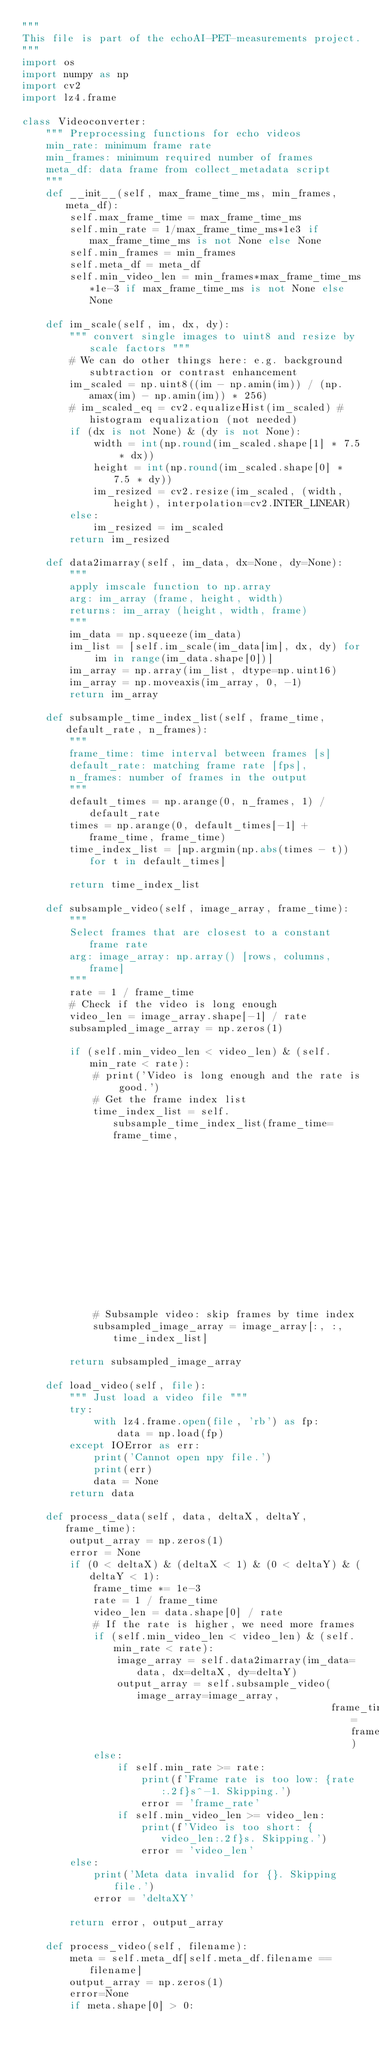<code> <loc_0><loc_0><loc_500><loc_500><_Python_>"""
This file is part of the echoAI-PET-measurements project.
"""
import os
import numpy as np
import cv2
import lz4.frame

class Videoconverter:
    """ Preprocessing functions for echo videos
    min_rate: minimum frame rate
    min_frames: minimum required number of frames
    meta_df: data frame from collect_metadata script
    """
    def __init__(self, max_frame_time_ms, min_frames, meta_df):
        self.max_frame_time = max_frame_time_ms
        self.min_rate = 1/max_frame_time_ms*1e3 if max_frame_time_ms is not None else None
        self.min_frames = min_frames
        self.meta_df = meta_df
        self.min_video_len = min_frames*max_frame_time_ms*1e-3 if max_frame_time_ms is not None else None

    def im_scale(self, im, dx, dy):
        """ convert single images to uint8 and resize by scale factors """
        # We can do other things here: e.g. background subtraction or contrast enhancement
        im_scaled = np.uint8((im - np.amin(im)) / (np.amax(im) - np.amin(im)) * 256)
        # im_scaled_eq = cv2.equalizeHist(im_scaled) # histogram equalization (not needed)
        if (dx is not None) & (dy is not None):
            width = int(np.round(im_scaled.shape[1] * 7.5 * dx))
            height = int(np.round(im_scaled.shape[0] * 7.5 * dy))
            im_resized = cv2.resize(im_scaled, (width, height), interpolation=cv2.INTER_LINEAR)
        else:
            im_resized = im_scaled
        return im_resized

    def data2imarray(self, im_data, dx=None, dy=None):
        """
        apply imscale function to np.array
        arg: im_array (frame, height, width)
        returns: im_array (height, width, frame)
        """
        im_data = np.squeeze(im_data)
        im_list = [self.im_scale(im_data[im], dx, dy) for im in range(im_data.shape[0])]
        im_array = np.array(im_list, dtype=np.uint16)
        im_array = np.moveaxis(im_array, 0, -1)
        return im_array

    def subsample_time_index_list(self, frame_time, default_rate, n_frames):
        """
        frame_time: time interval between frames [s]
        default_rate: matching frame rate [fps],
        n_frames: number of frames in the output
        """
        default_times = np.arange(0, n_frames, 1) / default_rate
        times = np.arange(0, default_times[-1] + frame_time, frame_time)
        time_index_list = [np.argmin(np.abs(times - t)) for t in default_times]

        return time_index_list

    def subsample_video(self, image_array, frame_time):
        """
        Select frames that are closest to a constant frame rate
        arg: image_array: np.array() [rows, columns, frame]
        """
        rate = 1 / frame_time
        # Check if the video is long enough
        video_len = image_array.shape[-1] / rate
        subsampled_image_array = np.zeros(1)

        if (self.min_video_len < video_len) & (self.min_rate < rate):
            # print('Video is long enough and the rate is good.')
            # Get the frame index list
            time_index_list = self.subsample_time_index_list(frame_time=frame_time,
                                                             default_rate=self.min_rate,
                                                             n_frames=self.min_frames)
            # Subsample video: skip frames by time index
            subsampled_image_array = image_array[:, :, time_index_list]

        return subsampled_image_array

    def load_video(self, file):
        """ Just load a video file """
        try:
            with lz4.frame.open(file, 'rb') as fp:
                data = np.load(fp)
        except IOError as err:
            print('Cannot open npy file.')
            print(err)
            data = None
        return data

    def process_data(self, data, deltaX, deltaY, frame_time):
        output_array = np.zeros(1)
        error = None
        if (0 < deltaX) & (deltaX < 1) & (0 < deltaY) & (deltaY < 1):
            frame_time *= 1e-3
            rate = 1 / frame_time
            video_len = data.shape[0] / rate
            # If the rate is higher, we need more frames
            if (self.min_video_len < video_len) & (self.min_rate < rate):
                image_array = self.data2imarray(im_data=data, dx=deltaX, dy=deltaY)
                output_array = self.subsample_video(image_array=image_array,
                                                    frame_time=frame_time)
            else:
                if self.min_rate >= rate:
                    print(f'Frame rate is too low: {rate:.2f}s^-1. Skipping.')
                    error = 'frame_rate'
                if self.min_video_len >= video_len:
                    print(f'Video is too short: {video_len:.2f}s. Skipping.')
                    error = 'video_len'
        else:
            print('Meta data invalid for {}. Skipping file.')
            error = 'deltaXY'

        return error, output_array

    def process_video(self, filename):
        meta = self.meta_df[self.meta_df.filename == filename]
        output_array = np.zeros(1)
        error=None
        if meta.shape[0] > 0:</code> 